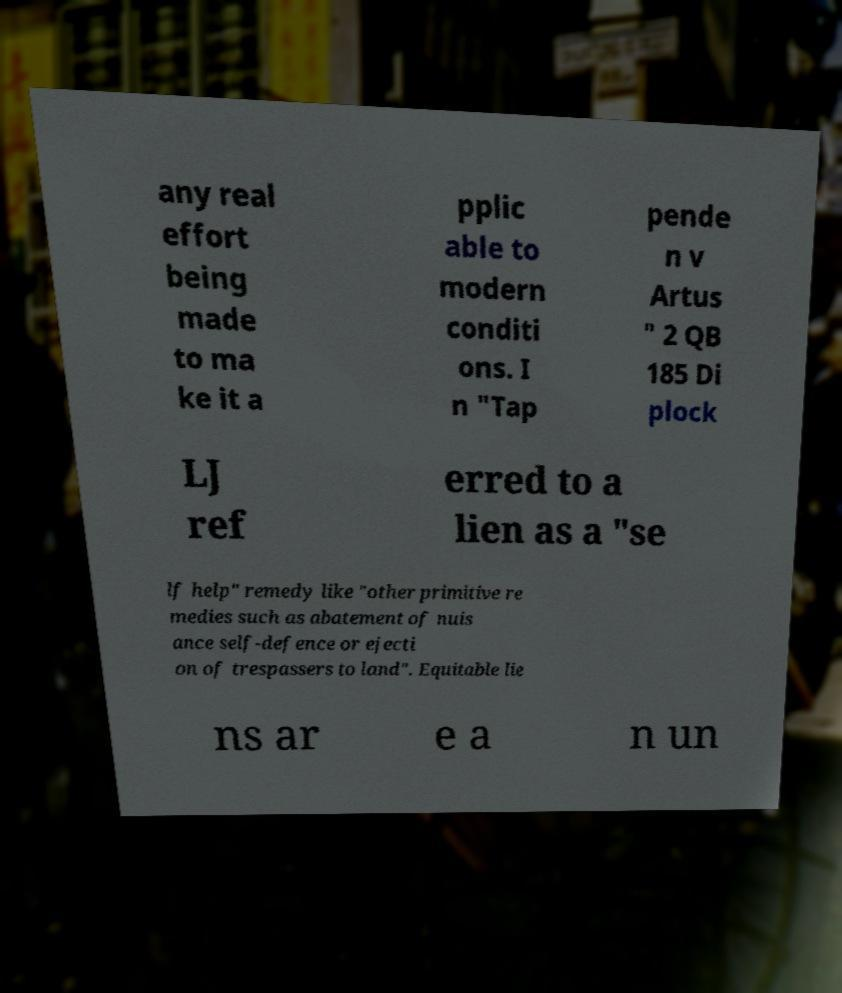Could you extract and type out the text from this image? any real effort being made to ma ke it a pplic able to modern conditi ons. I n "Tap pende n v Artus " 2 QB 185 Di plock LJ ref erred to a lien as a "se lf help" remedy like "other primitive re medies such as abatement of nuis ance self-defence or ejecti on of trespassers to land". Equitable lie ns ar e a n un 